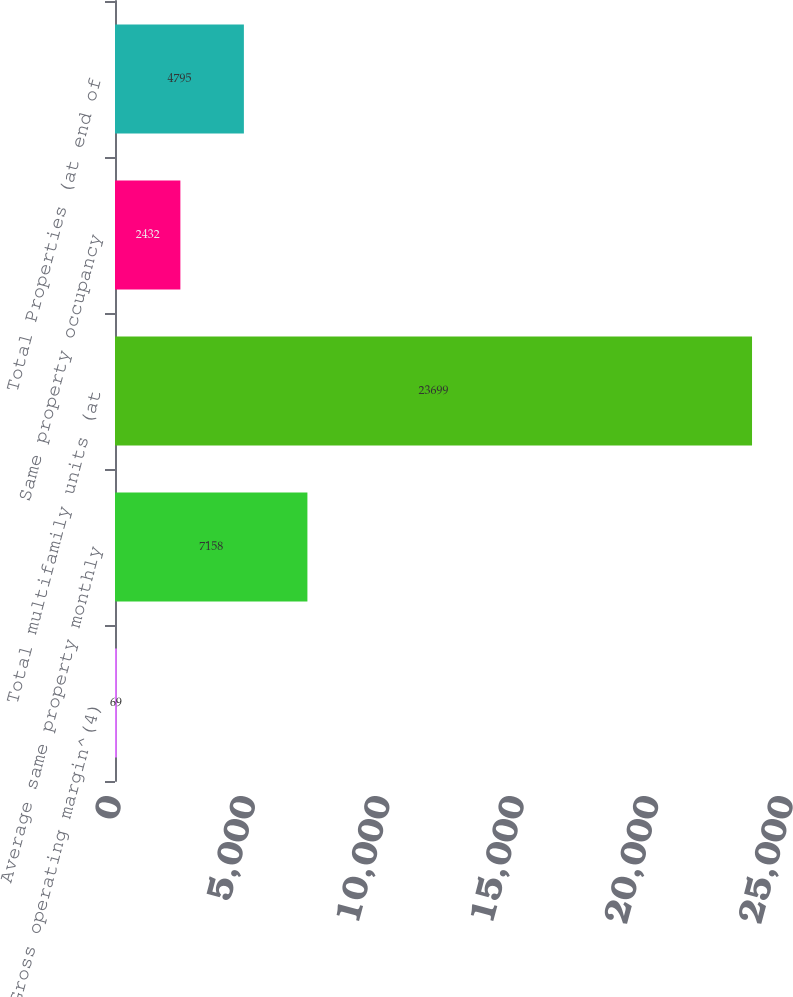Convert chart. <chart><loc_0><loc_0><loc_500><loc_500><bar_chart><fcel>Gross operating margin^(4)<fcel>Average same property monthly<fcel>Total multifamily units (at<fcel>Same property occupancy<fcel>Total Properties (at end of<nl><fcel>69<fcel>7158<fcel>23699<fcel>2432<fcel>4795<nl></chart> 